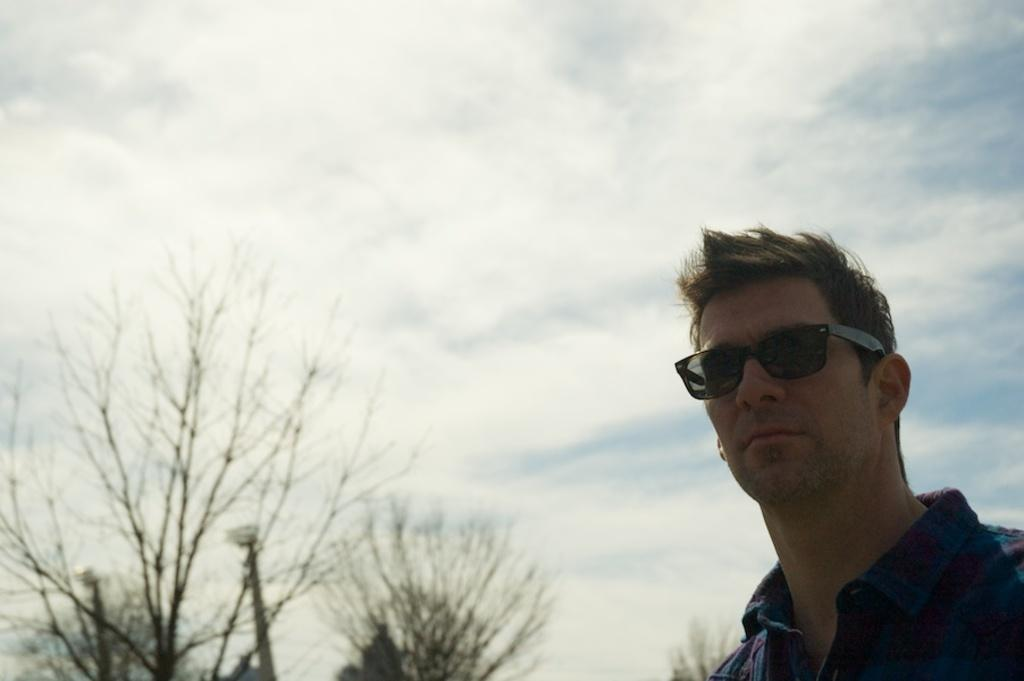Who is present in the image? There is a man in the image. What is the man wearing on his face? The man is wearing goggles. What can be seen on the left side of the image? There are trees on the left side of the image. What is visible in the background of the image? The sky is visible in the background of the image. How would you describe the sky in the image? The sky appears to be cloudy. What type of hen can be seen on the man's wrist in the image? There is no hen present in the image, nor is there any hen on the man's wrist. What color is the shoe worn by the man in the image? There is no shoe visible in the image; the man is wearing goggles, not shoes. 